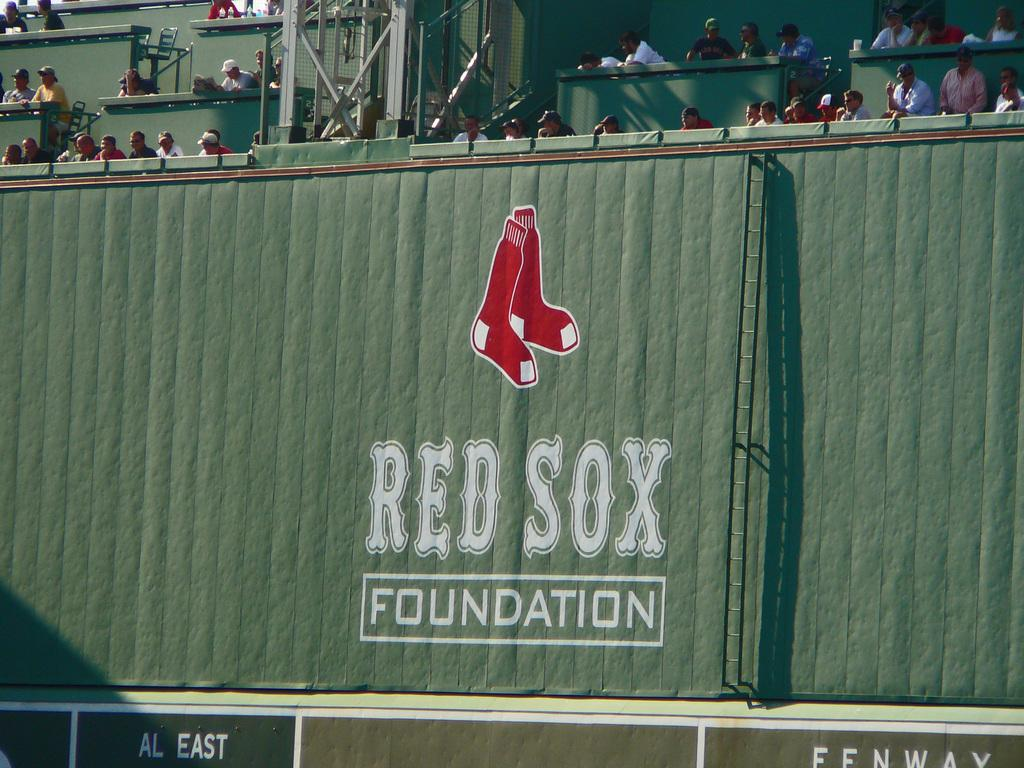<image>
Share a concise interpretation of the image provided. A wall that has a pair of red sox on it and says red sox foundation 